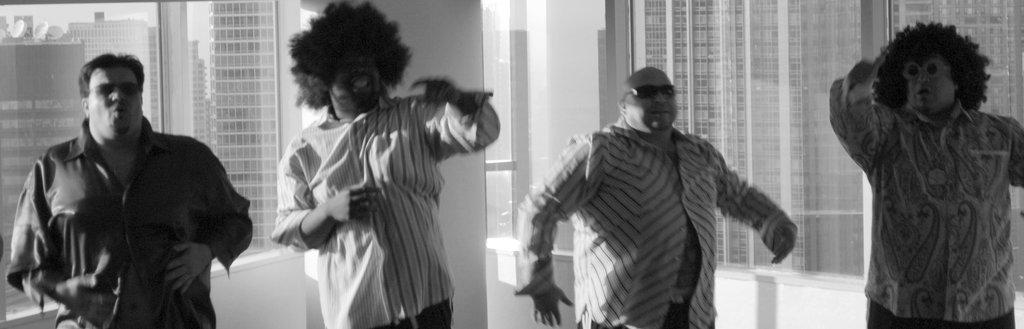How many people are in the image? There are four people in the image. What are the people doing in the image? The people are dancing. What is the color scheme of the image? The image is black and white. What can be seen in the background of the image? There are glass windows and buildings visible in the background of the image. How many horses are present in the image? There are no horses present in the image; it features four people dancing. What type of channel can be seen in the image? There is no channel present in the image; it is a black and white photograph of people dancing with a background of glass windows and buildings. 